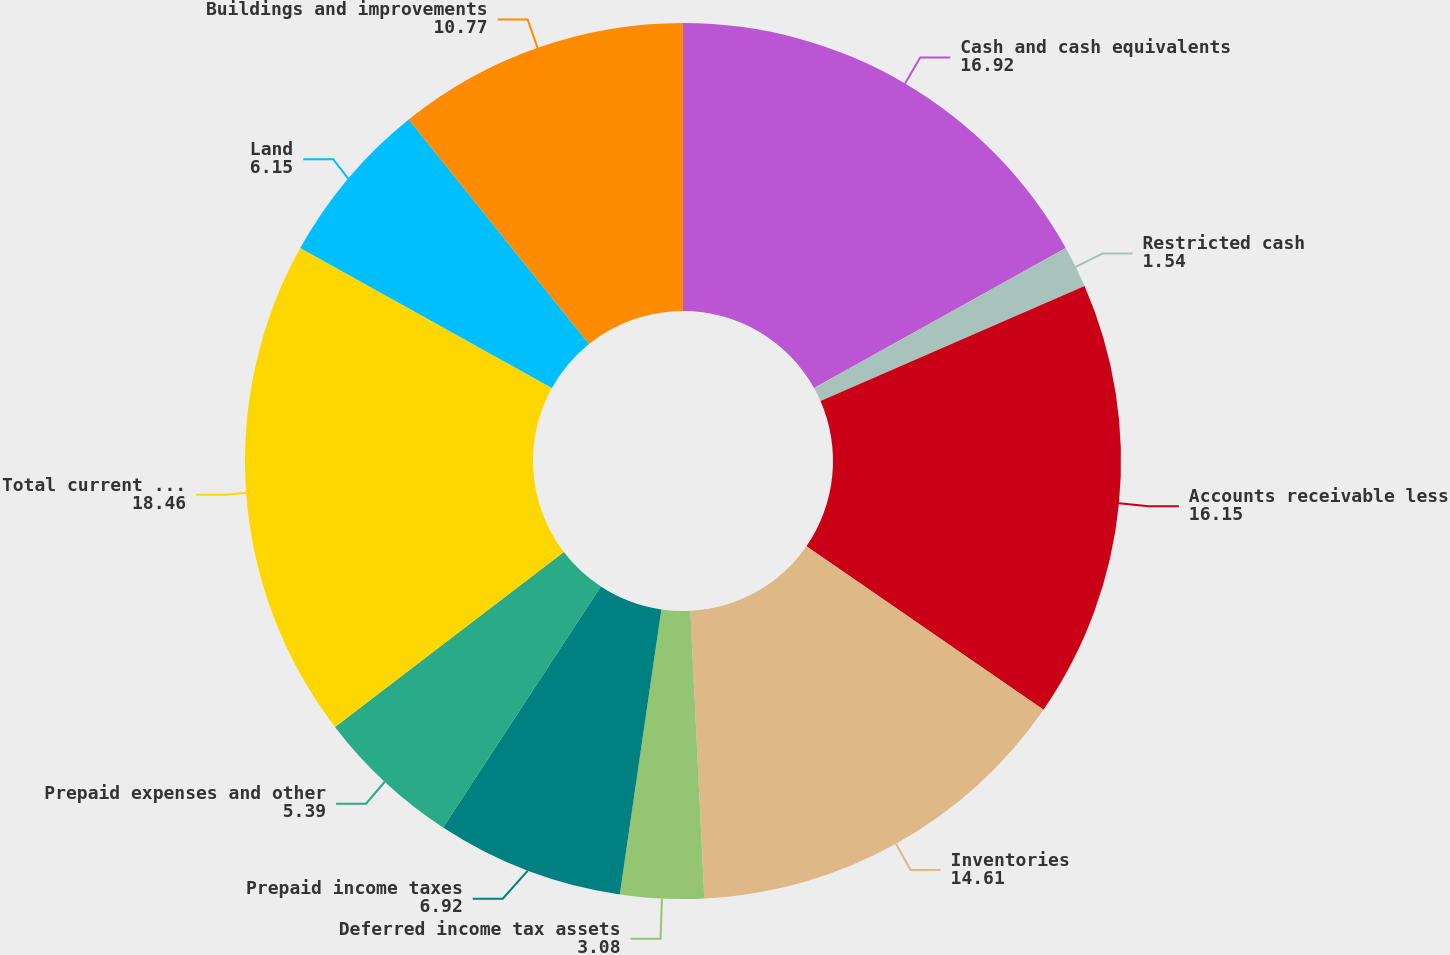Convert chart. <chart><loc_0><loc_0><loc_500><loc_500><pie_chart><fcel>Cash and cash equivalents<fcel>Restricted cash<fcel>Accounts receivable less<fcel>Inventories<fcel>Deferred income tax assets<fcel>Prepaid income taxes<fcel>Prepaid expenses and other<fcel>Total current assets<fcel>Land<fcel>Buildings and improvements<nl><fcel>16.92%<fcel>1.54%<fcel>16.15%<fcel>14.61%<fcel>3.08%<fcel>6.92%<fcel>5.39%<fcel>18.46%<fcel>6.15%<fcel>10.77%<nl></chart> 